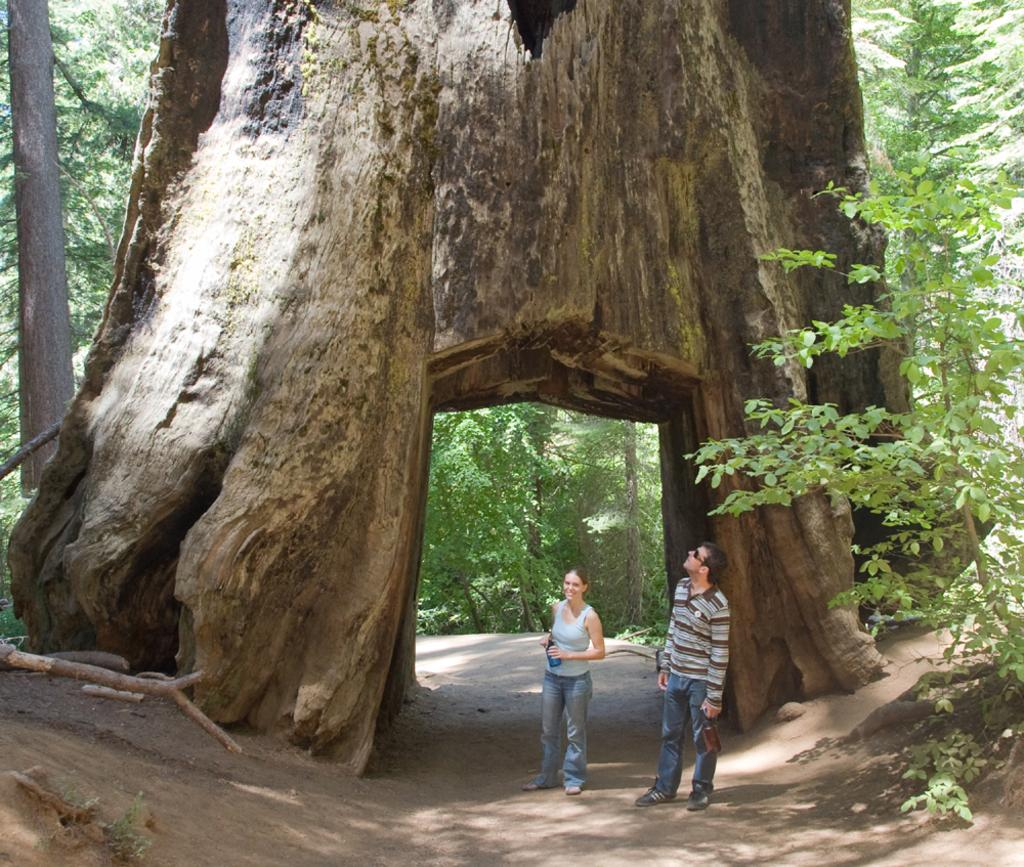How many people are present in the image? There are two people standing in the image. What can be seen in the background of the image? There are trees visible in the image. Is there any indication of a path or trail in the image? Yes, there is a path in the image. What type of pear is being destroyed in the middle of the image? There is no pear present in the image, nor is there any destruction taking place. 